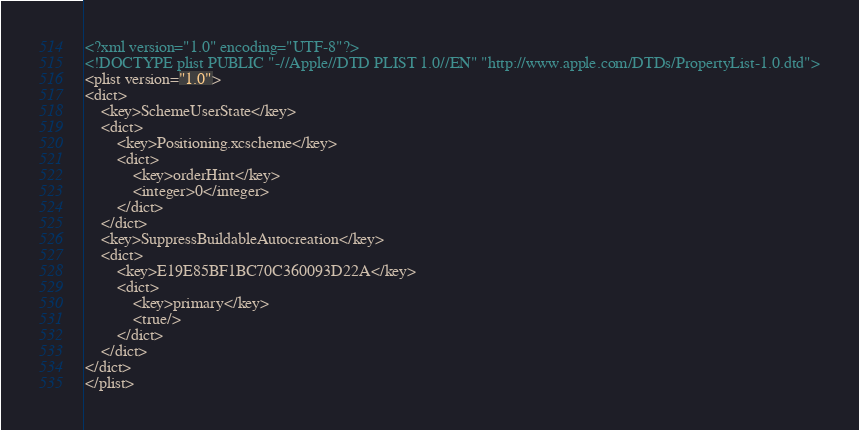Convert code to text. <code><loc_0><loc_0><loc_500><loc_500><_XML_><?xml version="1.0" encoding="UTF-8"?>
<!DOCTYPE plist PUBLIC "-//Apple//DTD PLIST 1.0//EN" "http://www.apple.com/DTDs/PropertyList-1.0.dtd">
<plist version="1.0">
<dict>
	<key>SchemeUserState</key>
	<dict>
		<key>Positioning.xcscheme</key>
		<dict>
			<key>orderHint</key>
			<integer>0</integer>
		</dict>
	</dict>
	<key>SuppressBuildableAutocreation</key>
	<dict>
		<key>E19E85BF1BC70C360093D22A</key>
		<dict>
			<key>primary</key>
			<true/>
		</dict>
	</dict>
</dict>
</plist>
</code> 